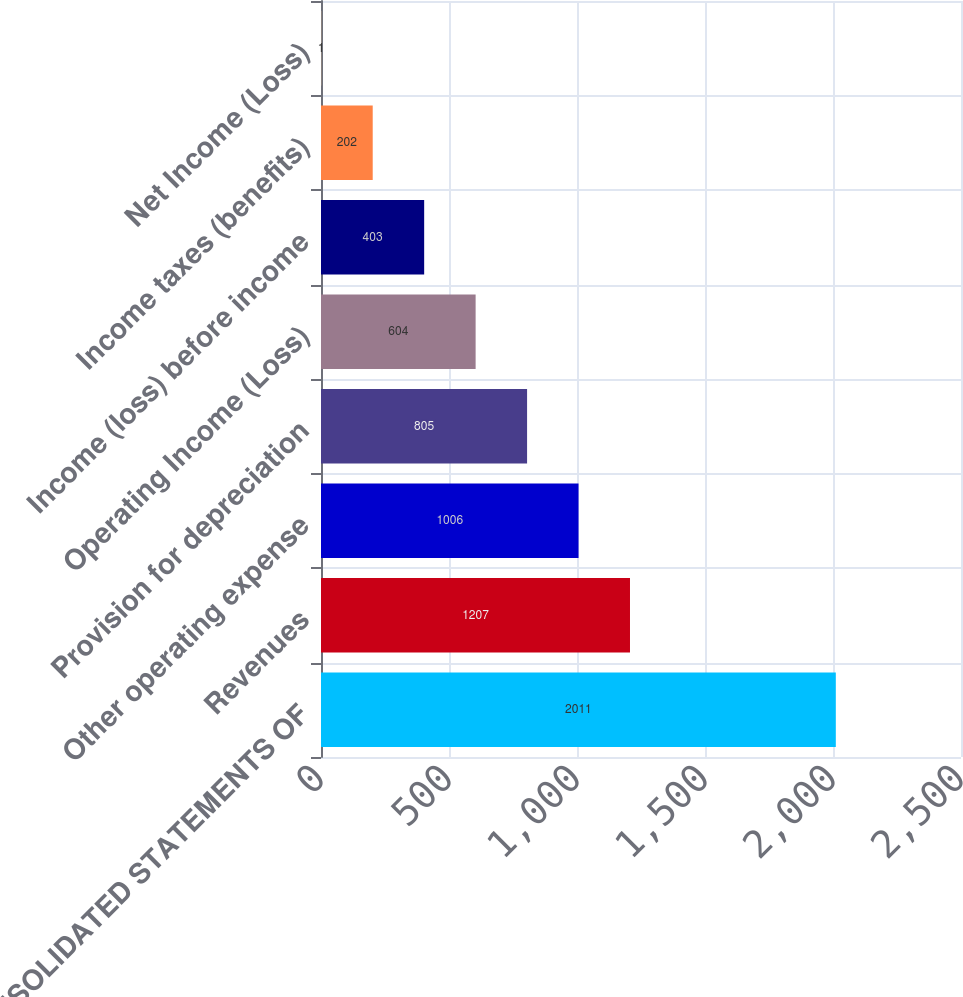Convert chart to OTSL. <chart><loc_0><loc_0><loc_500><loc_500><bar_chart><fcel>CONSOLIDATED STATEMENTS OF<fcel>Revenues<fcel>Other operating expense<fcel>Provision for depreciation<fcel>Operating Income (Loss)<fcel>Income (loss) before income<fcel>Income taxes (benefits)<fcel>Net Income (Loss)<nl><fcel>2011<fcel>1207<fcel>1006<fcel>805<fcel>604<fcel>403<fcel>202<fcel>1<nl></chart> 